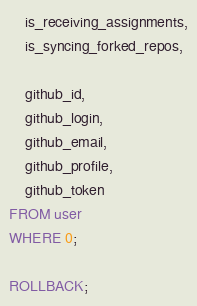Convert code to text. <code><loc_0><loc_0><loc_500><loc_500><_SQL_>
    is_receiving_assignments,
    is_syncing_forked_repos,

    github_id,
    github_login,
    github_email,
    github_profile,
    github_token
FROM user
WHERE 0;

ROLLBACK;
</code> 